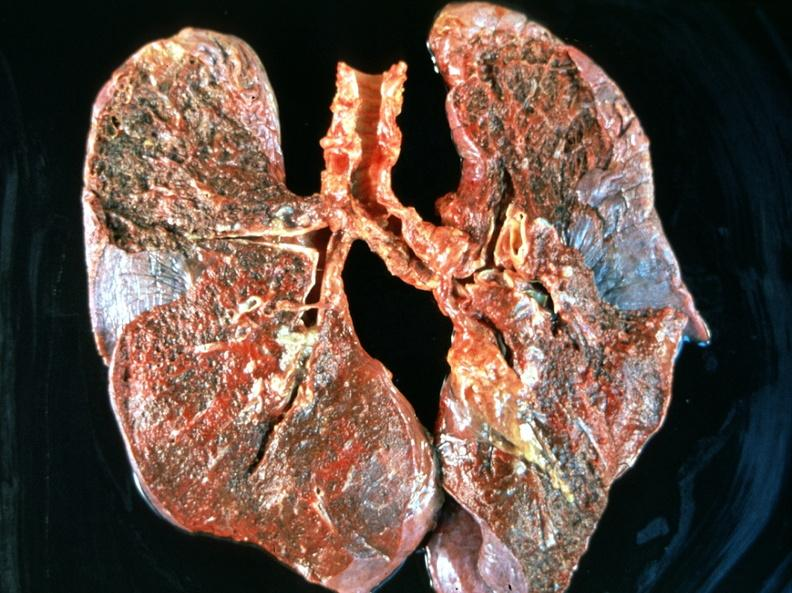what does this image show?
Answer the question using a single word or phrase. Breast cancer metastasis to lung 